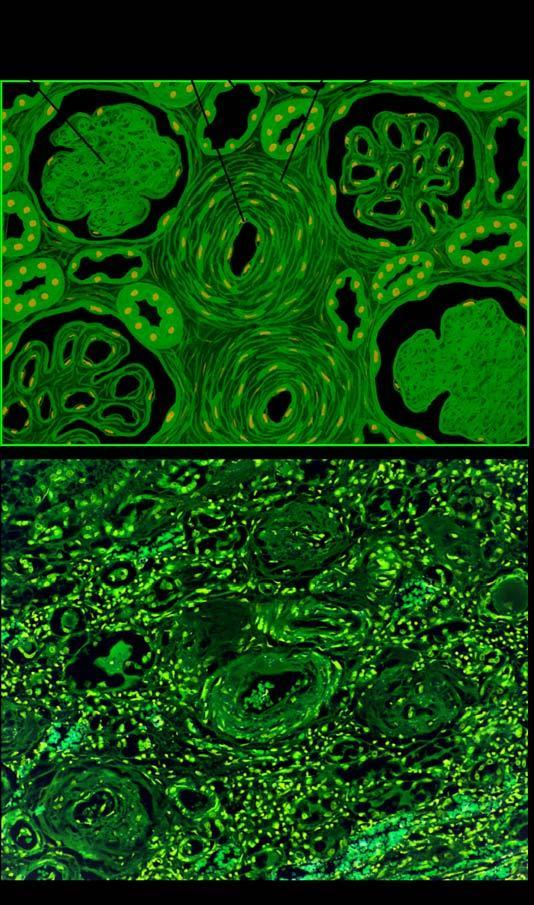re the vascular changes hyaline arteriolosclerosis and intimal thickening of small blood vessels in the glomerular tuft?
Answer the question using a single word or phrase. Yes 